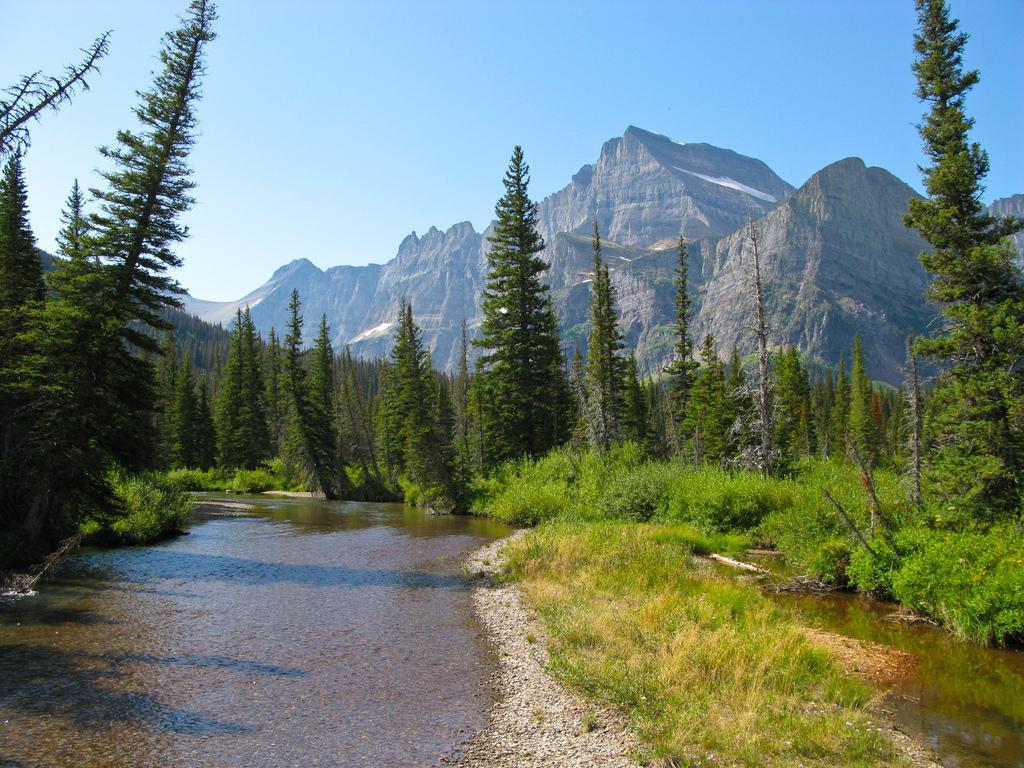How would you summarize this image in a sentence or two? In this picture we can see grass and water and in the background we can see trees, mountains and the sky. 